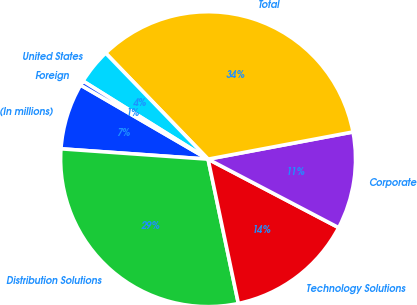<chart> <loc_0><loc_0><loc_500><loc_500><pie_chart><fcel>(In millions)<fcel>Distribution Solutions<fcel>Technology Solutions<fcel>Corporate<fcel>Total<fcel>United States<fcel>Foreign<nl><fcel>7.26%<fcel>29.41%<fcel>14.02%<fcel>10.64%<fcel>34.27%<fcel>3.89%<fcel>0.51%<nl></chart> 